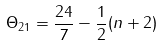Convert formula to latex. <formula><loc_0><loc_0><loc_500><loc_500>\Theta _ { 2 1 } = \frac { 2 4 } { 7 } - \frac { 1 } { 2 } ( n + 2 )</formula> 